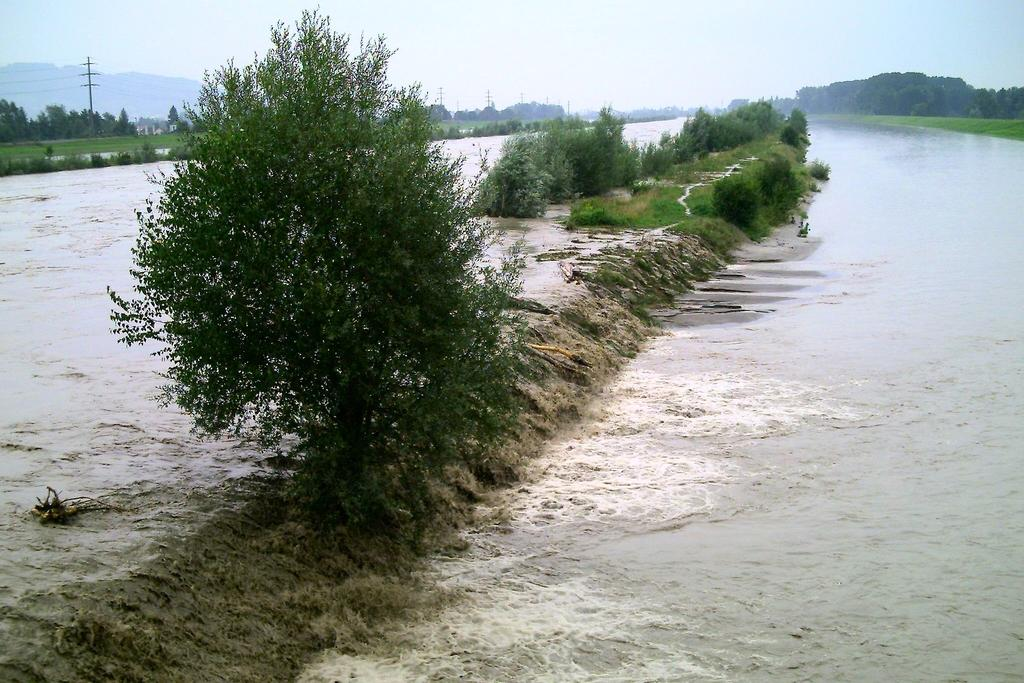What type of vegetation can be seen in the image? There are trees and plants in the image. What natural feature is present in the image? There is a river in the image. What structures can be seen in the image? Current poles are present in the image. What is visible in the background of the image? The sky is visible in the background of the image. Can you see any toes in the image? There are no toes visible in the image. 